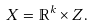<formula> <loc_0><loc_0><loc_500><loc_500>X = \mathbb { R } ^ { k } \times Z .</formula> 